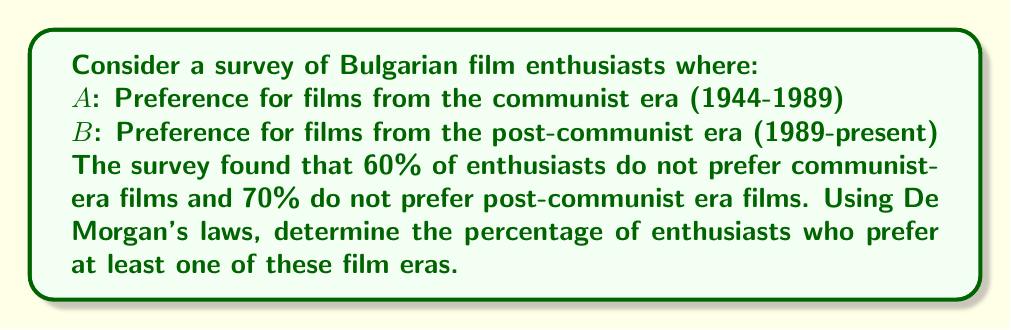Help me with this question. Let's approach this step-by-step:

1) First, let's define our sets:
   $A$: Preference for communist-era films
   $B$: Preference for post-communist era films

2) We're given:
   $P(\overline{A}) = 0.60$ (60% don't prefer communist-era films)
   $P(\overline{B}) = 0.70$ (70% don't prefer post-communist era films)

3) We want to find $P(A \cup B)$, the probability of preferring at least one era.

4) By De Morgan's laws:
   $\overline{A \cup B} = \overline{A} \cap \overline{B}$

5) Therefore:
   $P(A \cup B) = 1 - P(\overline{A \cup B}) = 1 - P(\overline{A} \cap \overline{B})$

6) Assuming independence (for simplicity):
   $P(\overline{A} \cap \overline{B}) = P(\overline{A}) \cdot P(\overline{B}) = 0.60 \cdot 0.70 = 0.42$

7) Thus:
   $P(A \cup B) = 1 - 0.42 = 0.58$

8) Converting to a percentage:
   $0.58 \cdot 100\% = 58\%$
Answer: 58% 